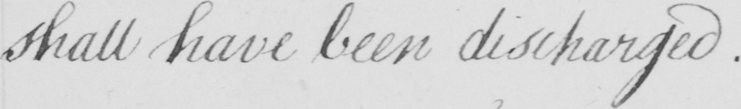What text is written in this handwritten line? shall have been discharged . 